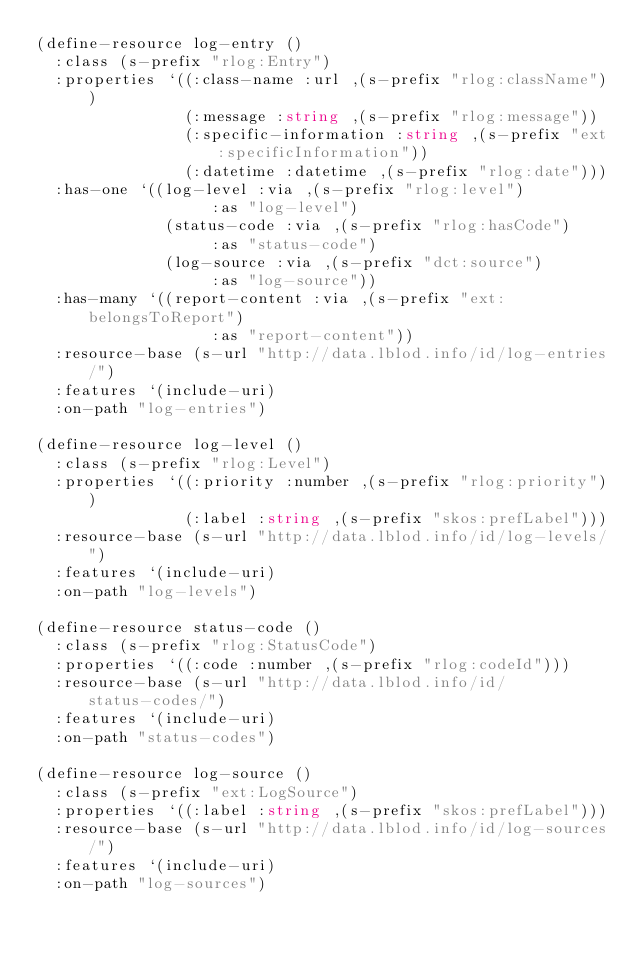Convert code to text. <code><loc_0><loc_0><loc_500><loc_500><_Lisp_>(define-resource log-entry ()
  :class (s-prefix "rlog:Entry")
  :properties `((:class-name :url ,(s-prefix "rlog:className"))
                (:message :string ,(s-prefix "rlog:message"))
                (:specific-information :string ,(s-prefix "ext:specificInformation"))
                (:datetime :datetime ,(s-prefix "rlog:date")))
  :has-one `((log-level :via ,(s-prefix "rlog:level")
                   :as "log-level")
              (status-code :via ,(s-prefix "rlog:hasCode")
                   :as "status-code")
              (log-source :via ,(s-prefix "dct:source")
                   :as "log-source"))
  :has-many `((report-content :via ,(s-prefix "ext:belongsToReport")
                   :as "report-content"))
  :resource-base (s-url "http://data.lblod.info/id/log-entries/")
  :features `(include-uri)
  :on-path "log-entries")

(define-resource log-level ()
  :class (s-prefix "rlog:Level")
  :properties `((:priority :number ,(s-prefix "rlog:priority"))
                (:label :string ,(s-prefix "skos:prefLabel")))
  :resource-base (s-url "http://data.lblod.info/id/log-levels/")
  :features `(include-uri)
  :on-path "log-levels")

(define-resource status-code ()
  :class (s-prefix "rlog:StatusCode")
  :properties `((:code :number ,(s-prefix "rlog:codeId")))
  :resource-base (s-url "http://data.lblod.info/id/status-codes/")
  :features `(include-uri)
  :on-path "status-codes")

(define-resource log-source ()
  :class (s-prefix "ext:LogSource")
  :properties `((:label :string ,(s-prefix "skos:prefLabel")))
  :resource-base (s-url "http://data.lblod.info/id/log-sources/")
  :features `(include-uri)
  :on-path "log-sources")
</code> 